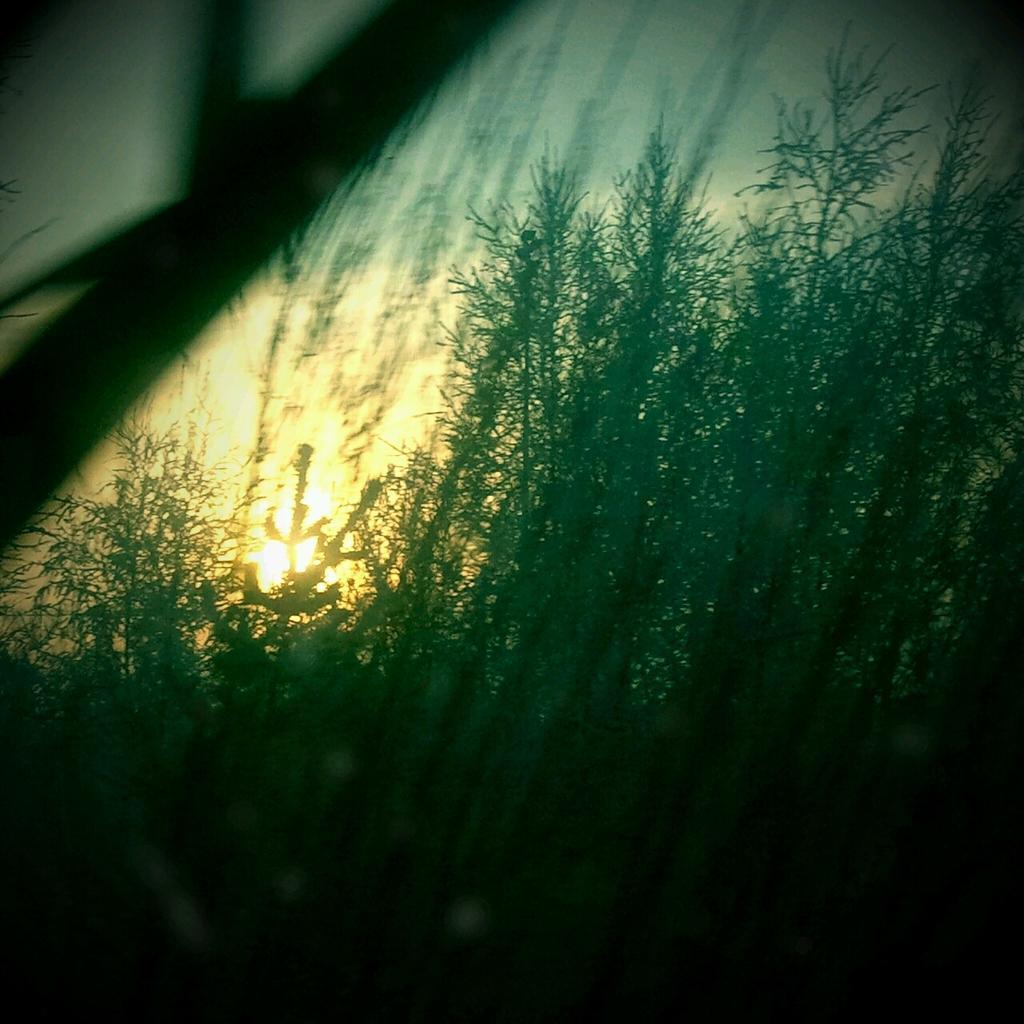In one or two sentences, can you explain what this image depicts? It is a beautiful sunrise picture,there are many plants and the sun is rising behind the plants. 